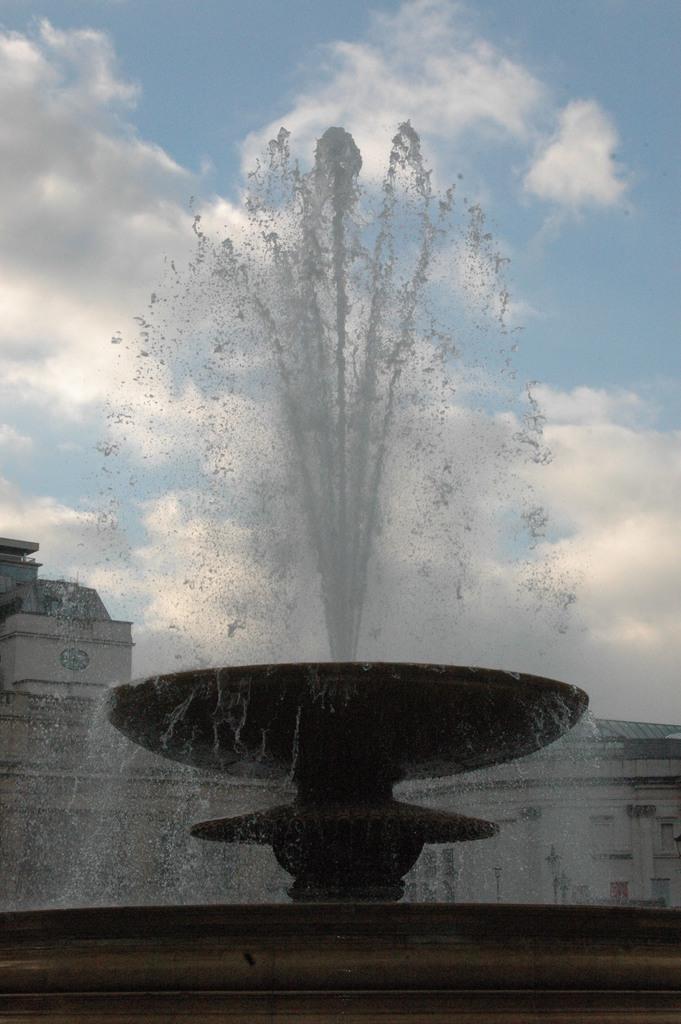Describe this image in one or two sentences. In this image I can see water fountain. In the background I can see buildings and the sky. 